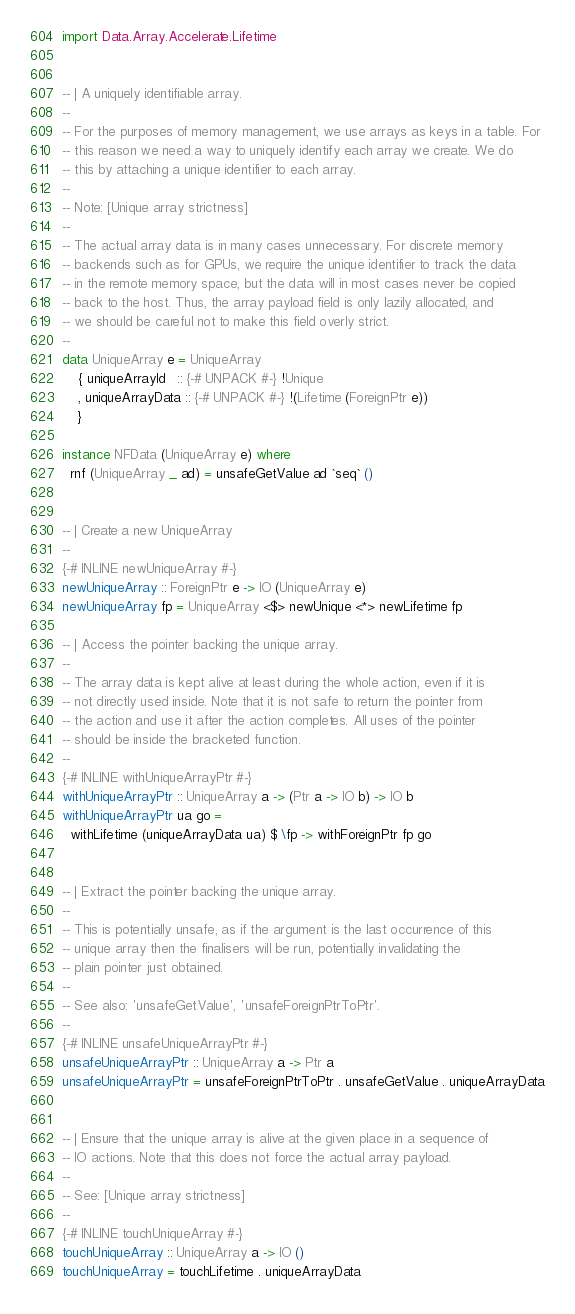<code> <loc_0><loc_0><loc_500><loc_500><_Haskell_>import Data.Array.Accelerate.Lifetime


-- | A uniquely identifiable array.
--
-- For the purposes of memory management, we use arrays as keys in a table. For
-- this reason we need a way to uniquely identify each array we create. We do
-- this by attaching a unique identifier to each array.
--
-- Note: [Unique array strictness]
--
-- The actual array data is in many cases unnecessary. For discrete memory
-- backends such as for GPUs, we require the unique identifier to track the data
-- in the remote memory space, but the data will in most cases never be copied
-- back to the host. Thus, the array payload field is only lazily allocated, and
-- we should be careful not to make this field overly strict.
--
data UniqueArray e = UniqueArray
    { uniqueArrayId   :: {-# UNPACK #-} !Unique
    , uniqueArrayData :: {-# UNPACK #-} !(Lifetime (ForeignPtr e))
    }

instance NFData (UniqueArray e) where
  rnf (UniqueArray _ ad) = unsafeGetValue ad `seq` ()


-- | Create a new UniqueArray
--
{-# INLINE newUniqueArray #-}
newUniqueArray :: ForeignPtr e -> IO (UniqueArray e)
newUniqueArray fp = UniqueArray <$> newUnique <*> newLifetime fp

-- | Access the pointer backing the unique array.
--
-- The array data is kept alive at least during the whole action, even if it is
-- not directly used inside. Note that it is not safe to return the pointer from
-- the action and use it after the action completes. All uses of the pointer
-- should be inside the bracketed function.
--
{-# INLINE withUniqueArrayPtr #-}
withUniqueArrayPtr :: UniqueArray a -> (Ptr a -> IO b) -> IO b
withUniqueArrayPtr ua go =
  withLifetime (uniqueArrayData ua) $ \fp -> withForeignPtr fp go


-- | Extract the pointer backing the unique array.
--
-- This is potentially unsafe, as if the argument is the last occurrence of this
-- unique array then the finalisers will be run, potentially invalidating the
-- plain pointer just obtained.
--
-- See also: 'unsafeGetValue', 'unsafeForeignPtrToPtr'.
--
{-# INLINE unsafeUniqueArrayPtr #-}
unsafeUniqueArrayPtr :: UniqueArray a -> Ptr a
unsafeUniqueArrayPtr = unsafeForeignPtrToPtr . unsafeGetValue . uniqueArrayData


-- | Ensure that the unique array is alive at the given place in a sequence of
-- IO actions. Note that this does not force the actual array payload.
--
-- See: [Unique array strictness]
--
{-# INLINE touchUniqueArray #-}
touchUniqueArray :: UniqueArray a -> IO ()
touchUniqueArray = touchLifetime . uniqueArrayData

</code> 